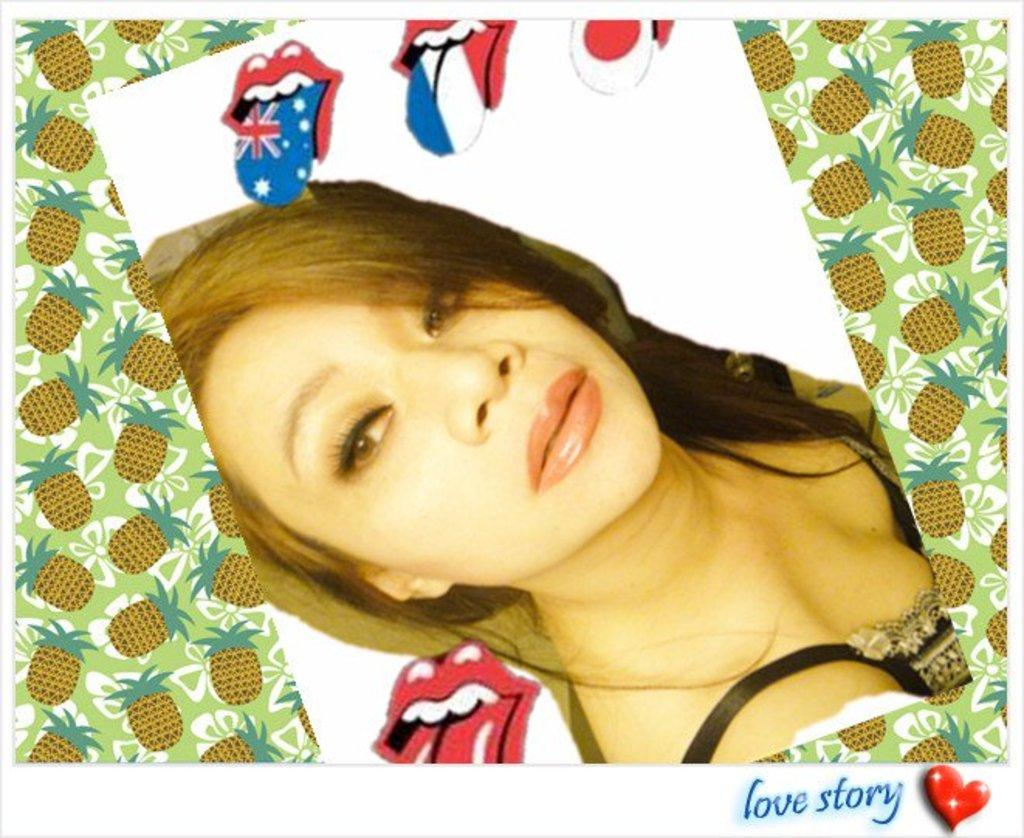What can be observed about the image? The image is edited. Who is present in the image? There is a girl in the image. What type of breakfast is being prepared in the image? There is no breakfast or any indication of food preparation in the image. 